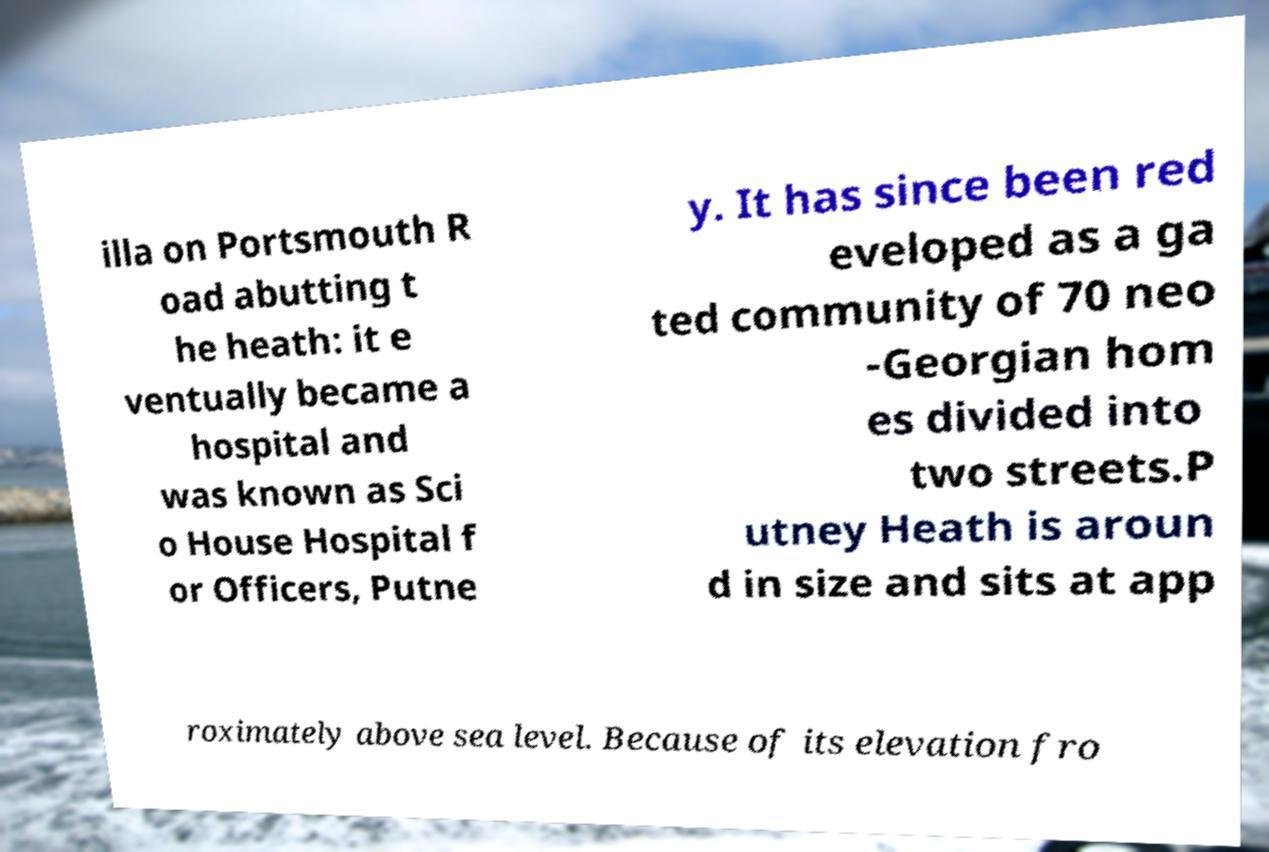Please read and relay the text visible in this image. What does it say? illa on Portsmouth R oad abutting t he heath: it e ventually became a hospital and was known as Sci o House Hospital f or Officers, Putne y. It has since been red eveloped as a ga ted community of 70 neo -Georgian hom es divided into two streets.P utney Heath is aroun d in size and sits at app roximately above sea level. Because of its elevation fro 